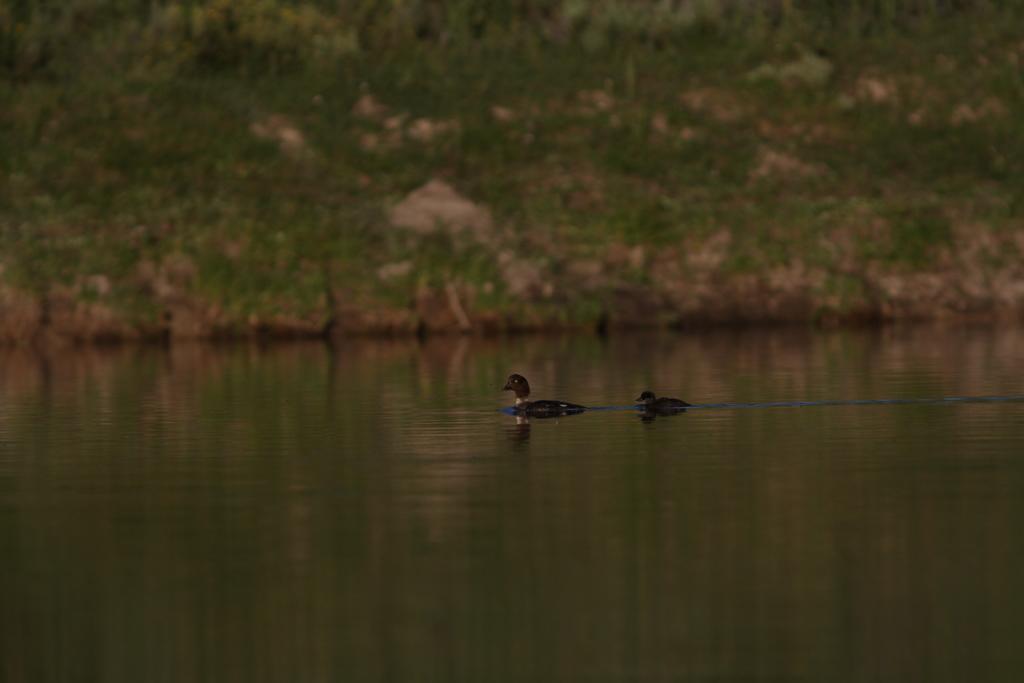How would you summarize this image in a sentence or two? In this picture I can see the ducks on the water, in the background there are plants. 